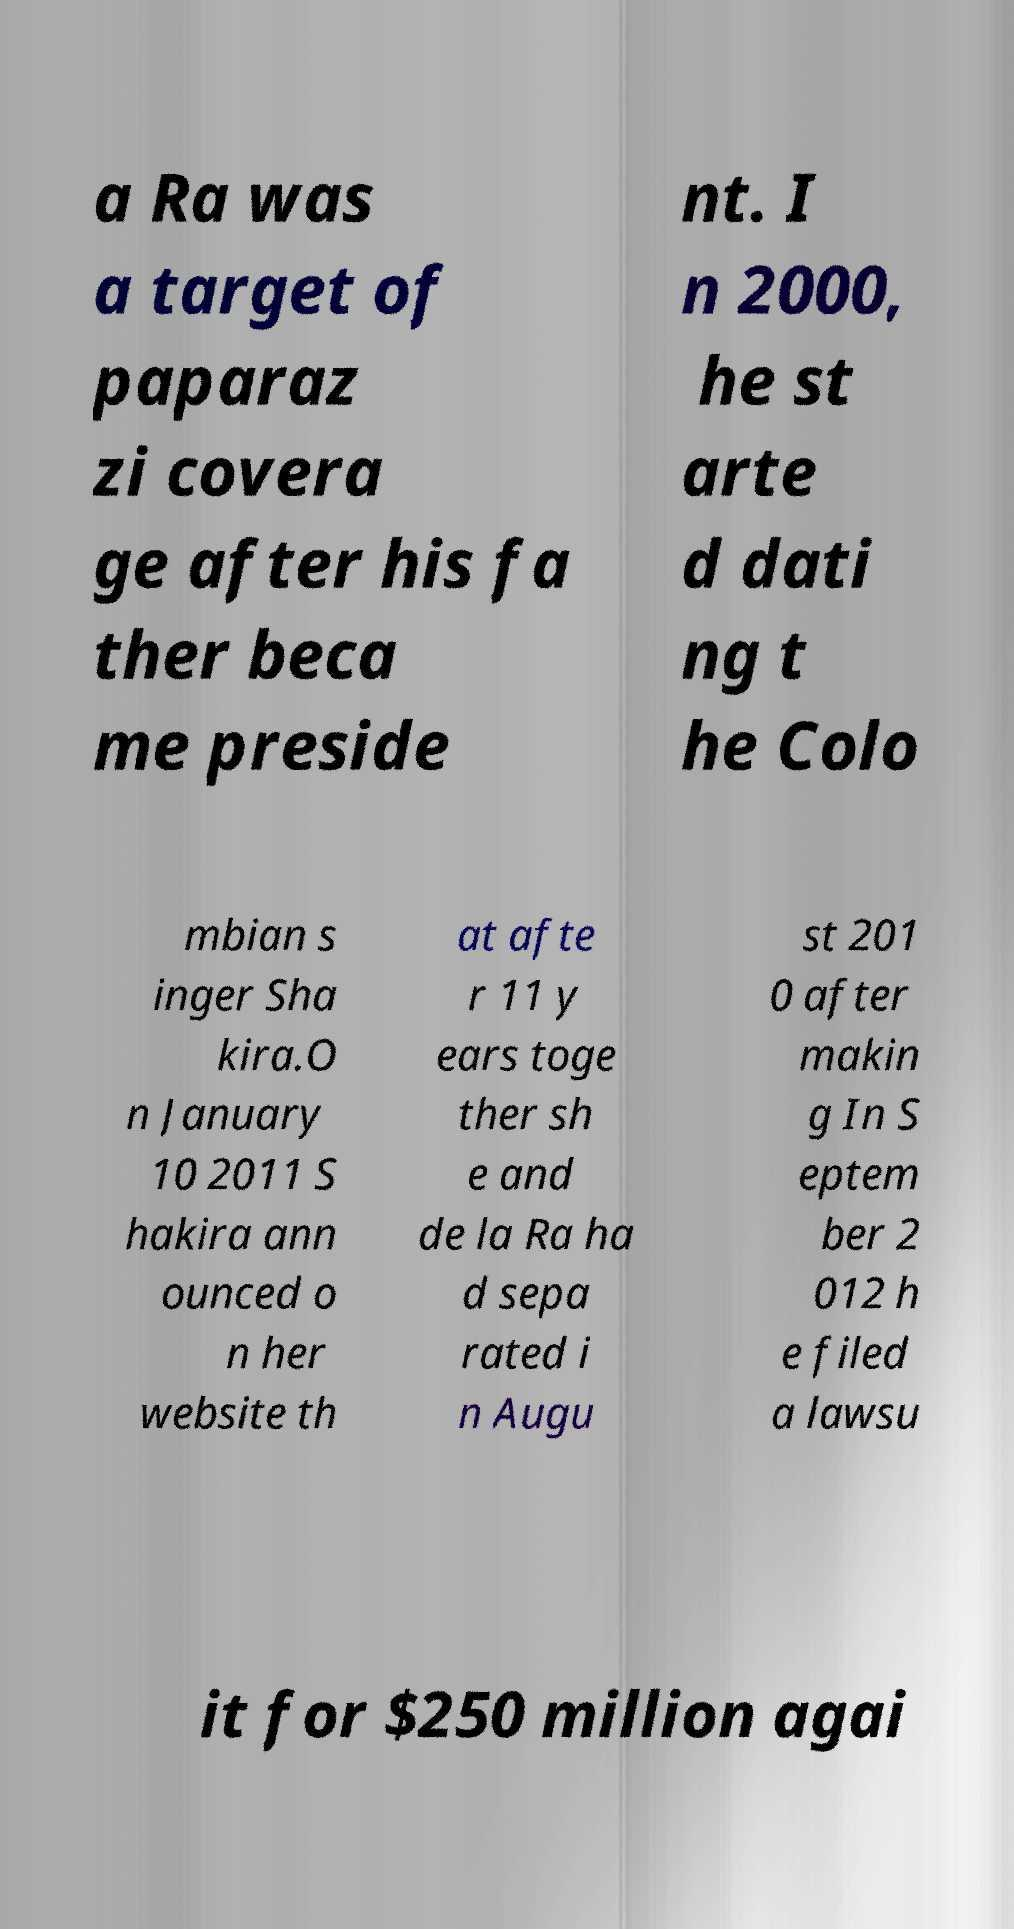Could you extract and type out the text from this image? a Ra was a target of paparaz zi covera ge after his fa ther beca me preside nt. I n 2000, he st arte d dati ng t he Colo mbian s inger Sha kira.O n January 10 2011 S hakira ann ounced o n her website th at afte r 11 y ears toge ther sh e and de la Ra ha d sepa rated i n Augu st 201 0 after makin g In S eptem ber 2 012 h e filed a lawsu it for $250 million agai 